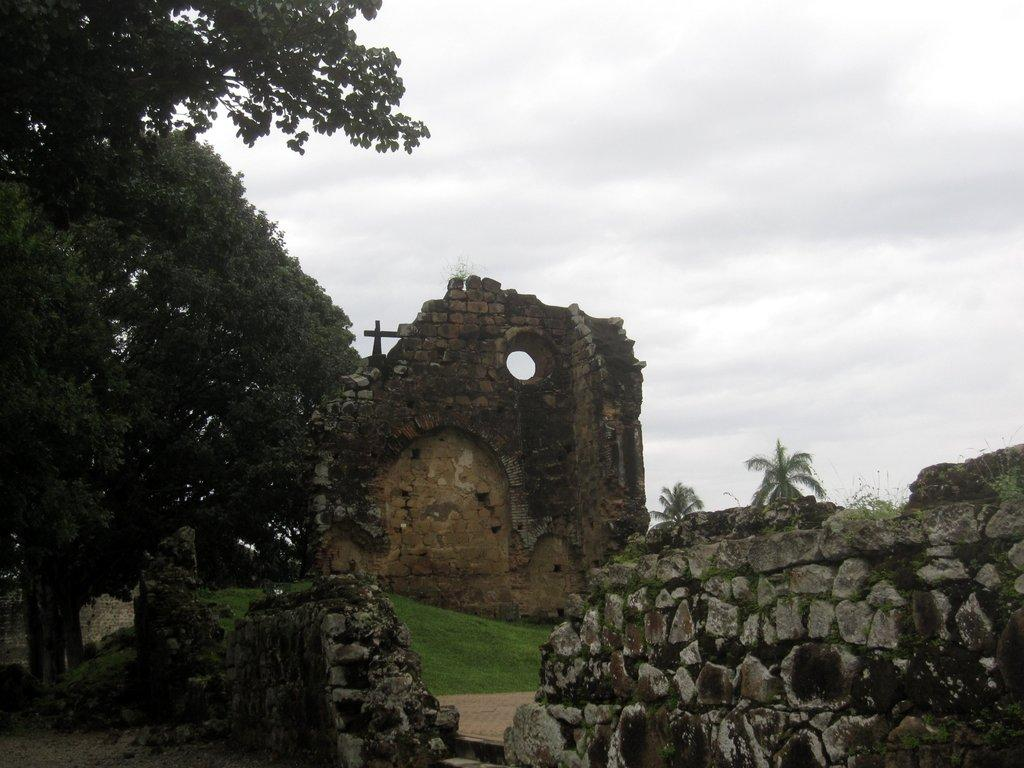What is the main structure made of in the image? The main structure in the image is made of bricks and rocks. What can be seen around the structure in the image? The structure is surrounded by greenery and trees. How would you describe the sky in the image? The sky appears gloomy in the image. What type of pen is being used to draw on the trees in the image? There is no pen or drawing activity present in the image; it features a structure surrounded by trees and a gloomy sky. 